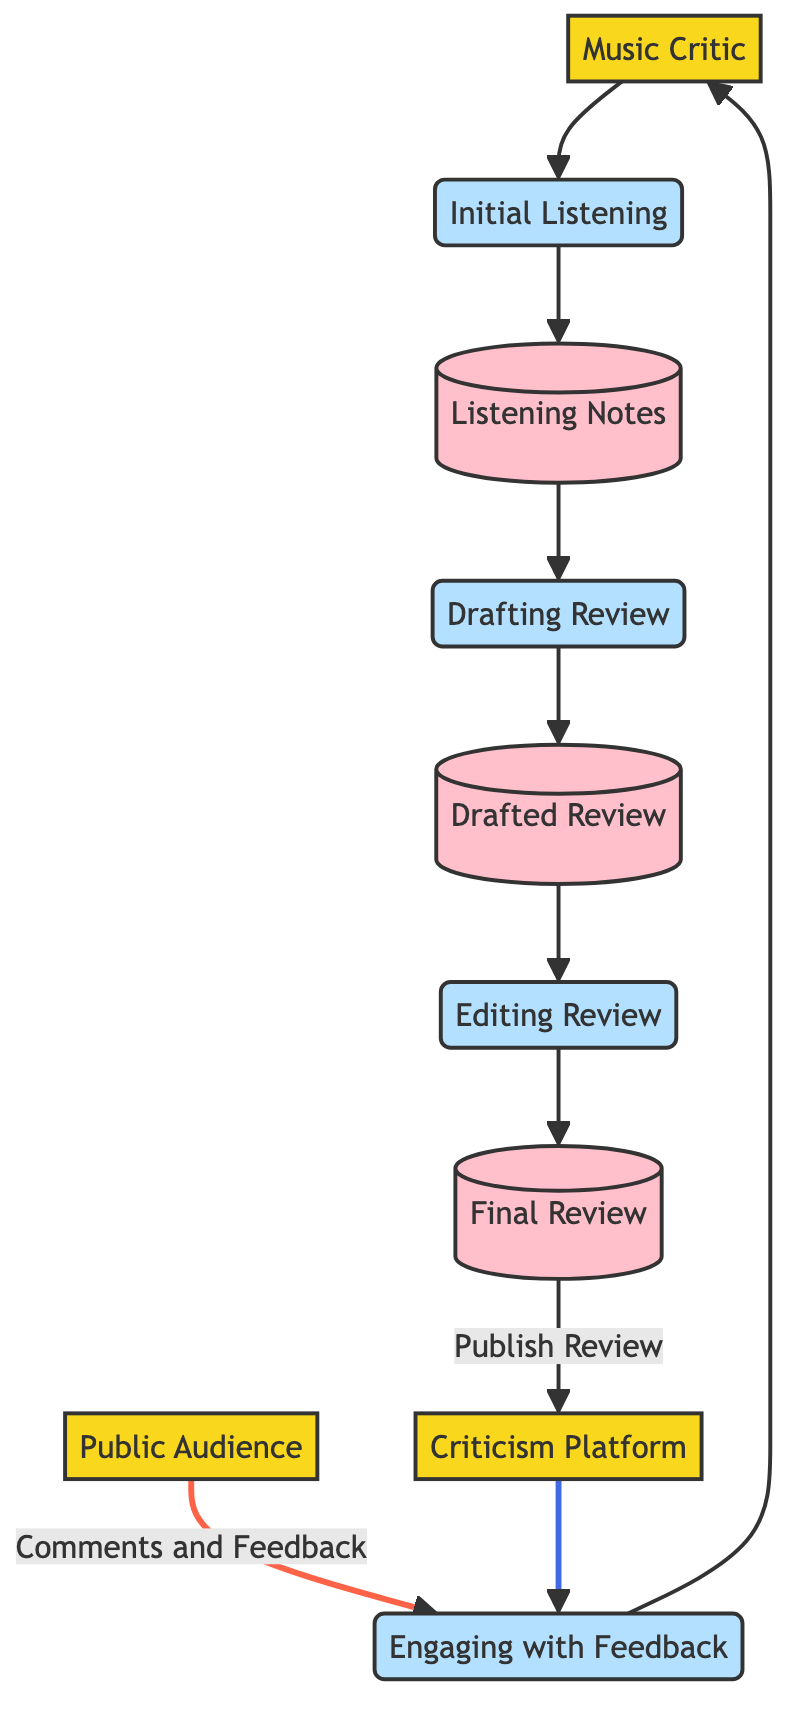What is the initial step in the review process? The diagram illustrates that the first step initiated by the Music Critic is "Initial Listening." This process is represented as the first node that the critic engages with before any notes or reviews are created.
Answer: Initial Listening How many processes are present in the diagram? By counting the elements classified as processes in the diagram, we identify the following: Initial Listening, Drafting Review, Editing Review, and Engaging with Feedback. There are four process nodes in total.
Answer: 4 What does the Music Critic do after drafting the review? The flow in the diagram shows that after the "Drafting Review" process, the critic proceeds to the "Editing Review" process. This step is crucial for refining the draft into a final version.
Answer: Editing Review Which entity receives comments and feedback from the Public Audience? The diagram indicates that the "Engaging with Feedback" process receives comments and feedback from the Public Audience as represented by the data flow labeled "Comments and Feedback."
Answer: Engaging with Feedback Where does the Final Review go after being published? According to the diagram, once the "Final Review" is published, it flows to the "Criticism Platform." This indicates that the finalized review is made public on the specified platform.
Answer: Criticism Platform Which process follows the "Drafting Review"? Based on the diagram, the process that directly follows "Drafting Review" is "Editing Review." This transition indicates that the drafted review is subsequently edited for finalization.
Answer: Editing Review What type of information is stored in the Listening Notes data store? The "Listening Notes" data store contains notes taken by the critic during or after the listening session. This information is essential for the subsequent drafting of the review.
Answer: Notes taken during or after the listening session How does the Public Audience interact with the review? The Public Audience interacts with the review through the process called "Engaging with Feedback," which is where they provide comments and feedback regarding the published review on the platform.
Answer: Engaging with Feedback How many data stores are shown in the diagram? Upon evaluating the diagram, we observe three data stores: Listening Notes, Drafted Review, and Final Review. Each of these stores holds different stages of information during the review lifecycle.
Answer: 3 